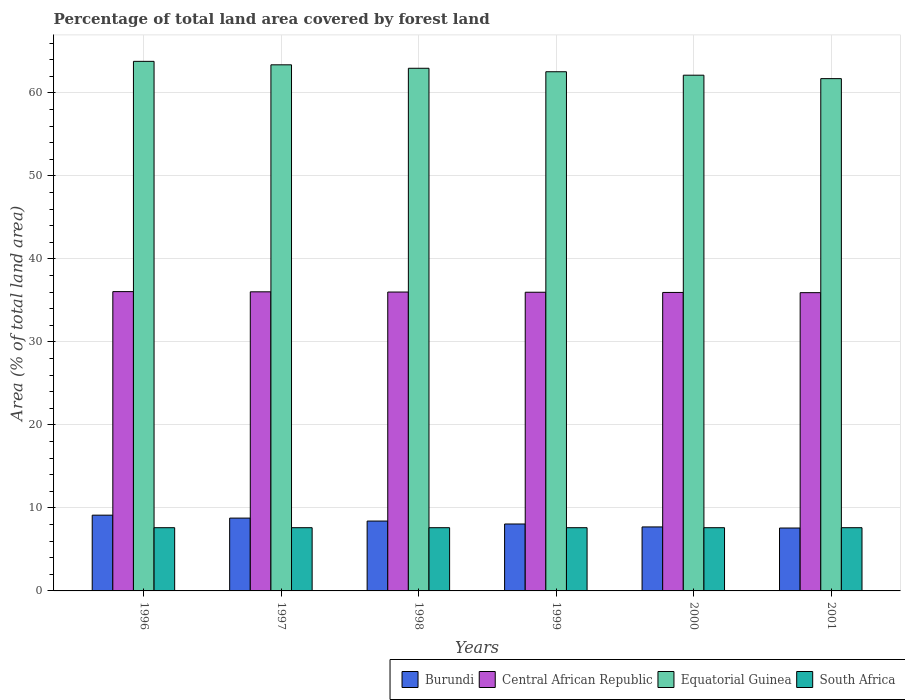How many groups of bars are there?
Offer a very short reply. 6. Are the number of bars per tick equal to the number of legend labels?
Your answer should be compact. Yes. Are the number of bars on each tick of the X-axis equal?
Your response must be concise. Yes. How many bars are there on the 1st tick from the left?
Offer a very short reply. 4. How many bars are there on the 5th tick from the right?
Provide a succinct answer. 4. What is the percentage of forest land in Burundi in 1999?
Provide a succinct answer. 8.06. Across all years, what is the maximum percentage of forest land in Burundi?
Offer a very short reply. 9.13. Across all years, what is the minimum percentage of forest land in Central African Republic?
Provide a succinct answer. 35.94. In which year was the percentage of forest land in Central African Republic maximum?
Keep it short and to the point. 1996. What is the total percentage of forest land in Equatorial Guinea in the graph?
Your response must be concise. 376.59. What is the difference between the percentage of forest land in Burundi in 1997 and that in 2000?
Make the answer very short. 1.06. What is the difference between the percentage of forest land in Equatorial Guinea in 2001 and the percentage of forest land in South Africa in 1999?
Your answer should be compact. 54.11. What is the average percentage of forest land in Burundi per year?
Ensure brevity in your answer.  8.28. In the year 1998, what is the difference between the percentage of forest land in Central African Republic and percentage of forest land in Equatorial Guinea?
Your answer should be compact. -26.96. What is the ratio of the percentage of forest land in Equatorial Guinea in 1997 to that in 1999?
Your response must be concise. 1.01. Is the percentage of forest land in Burundi in 1996 less than that in 2000?
Provide a succinct answer. No. Is the difference between the percentage of forest land in Central African Republic in 1998 and 2001 greater than the difference between the percentage of forest land in Equatorial Guinea in 1998 and 2001?
Your response must be concise. No. What is the difference between the highest and the second highest percentage of forest land in South Africa?
Keep it short and to the point. 0. What is the difference between the highest and the lowest percentage of forest land in Central African Republic?
Offer a terse response. 0.13. In how many years, is the percentage of forest land in South Africa greater than the average percentage of forest land in South Africa taken over all years?
Provide a short and direct response. 6. Is the sum of the percentage of forest land in South Africa in 1996 and 1997 greater than the maximum percentage of forest land in Central African Republic across all years?
Offer a very short reply. No. What does the 4th bar from the left in 2001 represents?
Provide a short and direct response. South Africa. What does the 1st bar from the right in 1997 represents?
Your answer should be very brief. South Africa. Is it the case that in every year, the sum of the percentage of forest land in South Africa and percentage of forest land in Burundi is greater than the percentage of forest land in Equatorial Guinea?
Ensure brevity in your answer.  No. Are all the bars in the graph horizontal?
Provide a short and direct response. No. What is the difference between two consecutive major ticks on the Y-axis?
Your answer should be compact. 10. Does the graph contain grids?
Your answer should be very brief. Yes. How are the legend labels stacked?
Provide a succinct answer. Horizontal. What is the title of the graph?
Your answer should be compact. Percentage of total land area covered by forest land. Does "Uzbekistan" appear as one of the legend labels in the graph?
Your response must be concise. No. What is the label or title of the X-axis?
Offer a terse response. Years. What is the label or title of the Y-axis?
Provide a succinct answer. Area (% of total land area). What is the Area (% of total land area) of Burundi in 1996?
Make the answer very short. 9.13. What is the Area (% of total land area) of Central African Republic in 1996?
Provide a succinct answer. 36.06. What is the Area (% of total land area) of Equatorial Guinea in 1996?
Your response must be concise. 63.81. What is the Area (% of total land area) in South Africa in 1996?
Your answer should be very brief. 7.62. What is the Area (% of total land area) in Burundi in 1997?
Provide a short and direct response. 8.77. What is the Area (% of total land area) in Central African Republic in 1997?
Make the answer very short. 36.04. What is the Area (% of total land area) in Equatorial Guinea in 1997?
Your answer should be compact. 63.39. What is the Area (% of total land area) in South Africa in 1997?
Offer a very short reply. 7.62. What is the Area (% of total land area) in Burundi in 1998?
Offer a terse response. 8.42. What is the Area (% of total land area) in Central African Republic in 1998?
Offer a very short reply. 36.01. What is the Area (% of total land area) in Equatorial Guinea in 1998?
Ensure brevity in your answer.  62.97. What is the Area (% of total land area) in South Africa in 1998?
Give a very brief answer. 7.62. What is the Area (% of total land area) of Burundi in 1999?
Offer a very short reply. 8.06. What is the Area (% of total land area) of Central African Republic in 1999?
Provide a short and direct response. 35.99. What is the Area (% of total land area) of Equatorial Guinea in 1999?
Give a very brief answer. 62.56. What is the Area (% of total land area) in South Africa in 1999?
Your answer should be very brief. 7.62. What is the Area (% of total land area) in Burundi in 2000?
Keep it short and to the point. 7.71. What is the Area (% of total land area) in Central African Republic in 2000?
Give a very brief answer. 35.96. What is the Area (% of total land area) in Equatorial Guinea in 2000?
Your response must be concise. 62.14. What is the Area (% of total land area) of South Africa in 2000?
Your answer should be compact. 7.62. What is the Area (% of total land area) of Burundi in 2001?
Provide a short and direct response. 7.58. What is the Area (% of total land area) in Central African Republic in 2001?
Your response must be concise. 35.94. What is the Area (% of total land area) in Equatorial Guinea in 2001?
Keep it short and to the point. 61.73. What is the Area (% of total land area) in South Africa in 2001?
Give a very brief answer. 7.62. Across all years, what is the maximum Area (% of total land area) in Burundi?
Your response must be concise. 9.13. Across all years, what is the maximum Area (% of total land area) of Central African Republic?
Ensure brevity in your answer.  36.06. Across all years, what is the maximum Area (% of total land area) in Equatorial Guinea?
Provide a short and direct response. 63.81. Across all years, what is the maximum Area (% of total land area) of South Africa?
Keep it short and to the point. 7.62. Across all years, what is the minimum Area (% of total land area) in Burundi?
Offer a terse response. 7.58. Across all years, what is the minimum Area (% of total land area) in Central African Republic?
Ensure brevity in your answer.  35.94. Across all years, what is the minimum Area (% of total land area) in Equatorial Guinea?
Your response must be concise. 61.73. Across all years, what is the minimum Area (% of total land area) in South Africa?
Keep it short and to the point. 7.62. What is the total Area (% of total land area) of Burundi in the graph?
Provide a short and direct response. 49.67. What is the total Area (% of total land area) of Central African Republic in the graph?
Provide a short and direct response. 216. What is the total Area (% of total land area) in Equatorial Guinea in the graph?
Ensure brevity in your answer.  376.59. What is the total Area (% of total land area) in South Africa in the graph?
Provide a short and direct response. 45.71. What is the difference between the Area (% of total land area) of Burundi in 1996 and that in 1997?
Keep it short and to the point. 0.35. What is the difference between the Area (% of total land area) of Central African Republic in 1996 and that in 1997?
Keep it short and to the point. 0.03. What is the difference between the Area (% of total land area) in Equatorial Guinea in 1996 and that in 1997?
Ensure brevity in your answer.  0.42. What is the difference between the Area (% of total land area) in Burundi in 1996 and that in 1998?
Your response must be concise. 0.71. What is the difference between the Area (% of total land area) of Central African Republic in 1996 and that in 1998?
Provide a succinct answer. 0.05. What is the difference between the Area (% of total land area) in Equatorial Guinea in 1996 and that in 1998?
Your response must be concise. 0.83. What is the difference between the Area (% of total land area) in South Africa in 1996 and that in 1998?
Make the answer very short. 0. What is the difference between the Area (% of total land area) in Burundi in 1996 and that in 1999?
Your response must be concise. 1.06. What is the difference between the Area (% of total land area) of Central African Republic in 1996 and that in 1999?
Offer a very short reply. 0.08. What is the difference between the Area (% of total land area) in Equatorial Guinea in 1996 and that in 1999?
Your answer should be very brief. 1.25. What is the difference between the Area (% of total land area) in Burundi in 1996 and that in 2000?
Your response must be concise. 1.42. What is the difference between the Area (% of total land area) in Central African Republic in 1996 and that in 2000?
Your answer should be very brief. 0.1. What is the difference between the Area (% of total land area) in Equatorial Guinea in 1996 and that in 2000?
Your answer should be compact. 1.67. What is the difference between the Area (% of total land area) of Burundi in 1996 and that in 2001?
Provide a succinct answer. 1.55. What is the difference between the Area (% of total land area) in Central African Republic in 1996 and that in 2001?
Keep it short and to the point. 0.13. What is the difference between the Area (% of total land area) in Equatorial Guinea in 1996 and that in 2001?
Provide a succinct answer. 2.08. What is the difference between the Area (% of total land area) in Burundi in 1997 and that in 1998?
Provide a short and direct response. 0.35. What is the difference between the Area (% of total land area) in Central African Republic in 1997 and that in 1998?
Keep it short and to the point. 0.03. What is the difference between the Area (% of total land area) in Equatorial Guinea in 1997 and that in 1998?
Keep it short and to the point. 0.42. What is the difference between the Area (% of total land area) of South Africa in 1997 and that in 1998?
Provide a succinct answer. 0. What is the difference between the Area (% of total land area) of Burundi in 1997 and that in 1999?
Ensure brevity in your answer.  0.71. What is the difference between the Area (% of total land area) of Central African Republic in 1997 and that in 1999?
Provide a short and direct response. 0.05. What is the difference between the Area (% of total land area) of Equatorial Guinea in 1997 and that in 1999?
Provide a short and direct response. 0.83. What is the difference between the Area (% of total land area) in South Africa in 1997 and that in 1999?
Offer a terse response. 0. What is the difference between the Area (% of total land area) of Burundi in 1997 and that in 2000?
Give a very brief answer. 1.06. What is the difference between the Area (% of total land area) of Central African Republic in 1997 and that in 2000?
Ensure brevity in your answer.  0.08. What is the difference between the Area (% of total land area) of Equatorial Guinea in 1997 and that in 2000?
Make the answer very short. 1.25. What is the difference between the Area (% of total land area) of South Africa in 1997 and that in 2000?
Ensure brevity in your answer.  0. What is the difference between the Area (% of total land area) in Burundi in 1997 and that in 2001?
Give a very brief answer. 1.2. What is the difference between the Area (% of total land area) in Central African Republic in 1997 and that in 2001?
Provide a succinct answer. 0.1. What is the difference between the Area (% of total land area) of Equatorial Guinea in 1997 and that in 2001?
Provide a short and direct response. 1.66. What is the difference between the Area (% of total land area) of Burundi in 1998 and that in 1999?
Offer a terse response. 0.35. What is the difference between the Area (% of total land area) of Central African Republic in 1998 and that in 1999?
Keep it short and to the point. 0.03. What is the difference between the Area (% of total land area) in Equatorial Guinea in 1998 and that in 1999?
Your response must be concise. 0.42. What is the difference between the Area (% of total land area) of South Africa in 1998 and that in 1999?
Your answer should be compact. 0. What is the difference between the Area (% of total land area) of Burundi in 1998 and that in 2000?
Provide a short and direct response. 0.71. What is the difference between the Area (% of total land area) in Central African Republic in 1998 and that in 2000?
Provide a succinct answer. 0.05. What is the difference between the Area (% of total land area) in Equatorial Guinea in 1998 and that in 2000?
Your response must be concise. 0.83. What is the difference between the Area (% of total land area) in Burundi in 1998 and that in 2001?
Provide a short and direct response. 0.84. What is the difference between the Area (% of total land area) in Central African Republic in 1998 and that in 2001?
Your response must be concise. 0.08. What is the difference between the Area (% of total land area) in Equatorial Guinea in 1998 and that in 2001?
Your answer should be very brief. 1.25. What is the difference between the Area (% of total land area) in Burundi in 1999 and that in 2000?
Make the answer very short. 0.35. What is the difference between the Area (% of total land area) of Central African Republic in 1999 and that in 2000?
Your answer should be very brief. 0.03. What is the difference between the Area (% of total land area) in Equatorial Guinea in 1999 and that in 2000?
Your response must be concise. 0.42. What is the difference between the Area (% of total land area) of South Africa in 1999 and that in 2000?
Keep it short and to the point. 0. What is the difference between the Area (% of total land area) of Burundi in 1999 and that in 2001?
Keep it short and to the point. 0.49. What is the difference between the Area (% of total land area) of Central African Republic in 1999 and that in 2001?
Keep it short and to the point. 0.05. What is the difference between the Area (% of total land area) in Equatorial Guinea in 1999 and that in 2001?
Your answer should be compact. 0.83. What is the difference between the Area (% of total land area) of Burundi in 2000 and that in 2001?
Your answer should be compact. 0.13. What is the difference between the Area (% of total land area) in Central African Republic in 2000 and that in 2001?
Ensure brevity in your answer.  0.03. What is the difference between the Area (% of total land area) of Equatorial Guinea in 2000 and that in 2001?
Your answer should be compact. 0.41. What is the difference between the Area (% of total land area) in South Africa in 2000 and that in 2001?
Make the answer very short. 0. What is the difference between the Area (% of total land area) in Burundi in 1996 and the Area (% of total land area) in Central African Republic in 1997?
Give a very brief answer. -26.91. What is the difference between the Area (% of total land area) in Burundi in 1996 and the Area (% of total land area) in Equatorial Guinea in 1997?
Keep it short and to the point. -54.26. What is the difference between the Area (% of total land area) of Burundi in 1996 and the Area (% of total land area) of South Africa in 1997?
Ensure brevity in your answer.  1.51. What is the difference between the Area (% of total land area) in Central African Republic in 1996 and the Area (% of total land area) in Equatorial Guinea in 1997?
Give a very brief answer. -27.33. What is the difference between the Area (% of total land area) in Central African Republic in 1996 and the Area (% of total land area) in South Africa in 1997?
Your answer should be compact. 28.45. What is the difference between the Area (% of total land area) of Equatorial Guinea in 1996 and the Area (% of total land area) of South Africa in 1997?
Offer a very short reply. 56.19. What is the difference between the Area (% of total land area) in Burundi in 1996 and the Area (% of total land area) in Central African Republic in 1998?
Your answer should be very brief. -26.89. What is the difference between the Area (% of total land area) in Burundi in 1996 and the Area (% of total land area) in Equatorial Guinea in 1998?
Keep it short and to the point. -53.85. What is the difference between the Area (% of total land area) in Burundi in 1996 and the Area (% of total land area) in South Africa in 1998?
Your response must be concise. 1.51. What is the difference between the Area (% of total land area) of Central African Republic in 1996 and the Area (% of total land area) of Equatorial Guinea in 1998?
Ensure brevity in your answer.  -26.91. What is the difference between the Area (% of total land area) of Central African Republic in 1996 and the Area (% of total land area) of South Africa in 1998?
Your response must be concise. 28.45. What is the difference between the Area (% of total land area) of Equatorial Guinea in 1996 and the Area (% of total land area) of South Africa in 1998?
Offer a terse response. 56.19. What is the difference between the Area (% of total land area) in Burundi in 1996 and the Area (% of total land area) in Central African Republic in 1999?
Give a very brief answer. -26.86. What is the difference between the Area (% of total land area) of Burundi in 1996 and the Area (% of total land area) of Equatorial Guinea in 1999?
Your answer should be very brief. -53.43. What is the difference between the Area (% of total land area) of Burundi in 1996 and the Area (% of total land area) of South Africa in 1999?
Offer a very short reply. 1.51. What is the difference between the Area (% of total land area) in Central African Republic in 1996 and the Area (% of total land area) in Equatorial Guinea in 1999?
Give a very brief answer. -26.49. What is the difference between the Area (% of total land area) of Central African Republic in 1996 and the Area (% of total land area) of South Africa in 1999?
Your answer should be compact. 28.45. What is the difference between the Area (% of total land area) in Equatorial Guinea in 1996 and the Area (% of total land area) in South Africa in 1999?
Your answer should be compact. 56.19. What is the difference between the Area (% of total land area) of Burundi in 1996 and the Area (% of total land area) of Central African Republic in 2000?
Give a very brief answer. -26.83. What is the difference between the Area (% of total land area) of Burundi in 1996 and the Area (% of total land area) of Equatorial Guinea in 2000?
Offer a very short reply. -53.01. What is the difference between the Area (% of total land area) in Burundi in 1996 and the Area (% of total land area) in South Africa in 2000?
Ensure brevity in your answer.  1.51. What is the difference between the Area (% of total land area) in Central African Republic in 1996 and the Area (% of total land area) in Equatorial Guinea in 2000?
Your answer should be very brief. -26.08. What is the difference between the Area (% of total land area) in Central African Republic in 1996 and the Area (% of total land area) in South Africa in 2000?
Your answer should be compact. 28.45. What is the difference between the Area (% of total land area) of Equatorial Guinea in 1996 and the Area (% of total land area) of South Africa in 2000?
Offer a very short reply. 56.19. What is the difference between the Area (% of total land area) of Burundi in 1996 and the Area (% of total land area) of Central African Republic in 2001?
Make the answer very short. -26.81. What is the difference between the Area (% of total land area) in Burundi in 1996 and the Area (% of total land area) in Equatorial Guinea in 2001?
Keep it short and to the point. -52.6. What is the difference between the Area (% of total land area) in Burundi in 1996 and the Area (% of total land area) in South Africa in 2001?
Your answer should be very brief. 1.51. What is the difference between the Area (% of total land area) in Central African Republic in 1996 and the Area (% of total land area) in Equatorial Guinea in 2001?
Keep it short and to the point. -25.66. What is the difference between the Area (% of total land area) in Central African Republic in 1996 and the Area (% of total land area) in South Africa in 2001?
Make the answer very short. 28.45. What is the difference between the Area (% of total land area) in Equatorial Guinea in 1996 and the Area (% of total land area) in South Africa in 2001?
Ensure brevity in your answer.  56.19. What is the difference between the Area (% of total land area) in Burundi in 1997 and the Area (% of total land area) in Central African Republic in 1998?
Make the answer very short. -27.24. What is the difference between the Area (% of total land area) of Burundi in 1997 and the Area (% of total land area) of Equatorial Guinea in 1998?
Ensure brevity in your answer.  -54.2. What is the difference between the Area (% of total land area) in Burundi in 1997 and the Area (% of total land area) in South Africa in 1998?
Provide a short and direct response. 1.16. What is the difference between the Area (% of total land area) in Central African Republic in 1997 and the Area (% of total land area) in Equatorial Guinea in 1998?
Your answer should be very brief. -26.94. What is the difference between the Area (% of total land area) in Central African Republic in 1997 and the Area (% of total land area) in South Africa in 1998?
Your response must be concise. 28.42. What is the difference between the Area (% of total land area) in Equatorial Guinea in 1997 and the Area (% of total land area) in South Africa in 1998?
Give a very brief answer. 55.77. What is the difference between the Area (% of total land area) in Burundi in 1997 and the Area (% of total land area) in Central African Republic in 1999?
Your answer should be very brief. -27.21. What is the difference between the Area (% of total land area) of Burundi in 1997 and the Area (% of total land area) of Equatorial Guinea in 1999?
Offer a terse response. -53.78. What is the difference between the Area (% of total land area) in Burundi in 1997 and the Area (% of total land area) in South Africa in 1999?
Make the answer very short. 1.16. What is the difference between the Area (% of total land area) of Central African Republic in 1997 and the Area (% of total land area) of Equatorial Guinea in 1999?
Keep it short and to the point. -26.52. What is the difference between the Area (% of total land area) in Central African Republic in 1997 and the Area (% of total land area) in South Africa in 1999?
Offer a very short reply. 28.42. What is the difference between the Area (% of total land area) in Equatorial Guinea in 1997 and the Area (% of total land area) in South Africa in 1999?
Provide a short and direct response. 55.77. What is the difference between the Area (% of total land area) of Burundi in 1997 and the Area (% of total land area) of Central African Republic in 2000?
Give a very brief answer. -27.19. What is the difference between the Area (% of total land area) of Burundi in 1997 and the Area (% of total land area) of Equatorial Guinea in 2000?
Your answer should be very brief. -53.37. What is the difference between the Area (% of total land area) of Burundi in 1997 and the Area (% of total land area) of South Africa in 2000?
Ensure brevity in your answer.  1.16. What is the difference between the Area (% of total land area) in Central African Republic in 1997 and the Area (% of total land area) in Equatorial Guinea in 2000?
Your answer should be very brief. -26.1. What is the difference between the Area (% of total land area) in Central African Republic in 1997 and the Area (% of total land area) in South Africa in 2000?
Offer a terse response. 28.42. What is the difference between the Area (% of total land area) in Equatorial Guinea in 1997 and the Area (% of total land area) in South Africa in 2000?
Offer a terse response. 55.77. What is the difference between the Area (% of total land area) of Burundi in 1997 and the Area (% of total land area) of Central African Republic in 2001?
Offer a very short reply. -27.16. What is the difference between the Area (% of total land area) in Burundi in 1997 and the Area (% of total land area) in Equatorial Guinea in 2001?
Offer a terse response. -52.95. What is the difference between the Area (% of total land area) in Burundi in 1997 and the Area (% of total land area) in South Africa in 2001?
Make the answer very short. 1.16. What is the difference between the Area (% of total land area) of Central African Republic in 1997 and the Area (% of total land area) of Equatorial Guinea in 2001?
Keep it short and to the point. -25.69. What is the difference between the Area (% of total land area) in Central African Republic in 1997 and the Area (% of total land area) in South Africa in 2001?
Give a very brief answer. 28.42. What is the difference between the Area (% of total land area) of Equatorial Guinea in 1997 and the Area (% of total land area) of South Africa in 2001?
Make the answer very short. 55.77. What is the difference between the Area (% of total land area) of Burundi in 1998 and the Area (% of total land area) of Central African Republic in 1999?
Your answer should be very brief. -27.57. What is the difference between the Area (% of total land area) in Burundi in 1998 and the Area (% of total land area) in Equatorial Guinea in 1999?
Keep it short and to the point. -54.14. What is the difference between the Area (% of total land area) of Burundi in 1998 and the Area (% of total land area) of South Africa in 1999?
Give a very brief answer. 0.8. What is the difference between the Area (% of total land area) of Central African Republic in 1998 and the Area (% of total land area) of Equatorial Guinea in 1999?
Your response must be concise. -26.54. What is the difference between the Area (% of total land area) in Central African Republic in 1998 and the Area (% of total land area) in South Africa in 1999?
Offer a terse response. 28.39. What is the difference between the Area (% of total land area) in Equatorial Guinea in 1998 and the Area (% of total land area) in South Africa in 1999?
Offer a terse response. 55.36. What is the difference between the Area (% of total land area) in Burundi in 1998 and the Area (% of total land area) in Central African Republic in 2000?
Your answer should be compact. -27.54. What is the difference between the Area (% of total land area) in Burundi in 1998 and the Area (% of total land area) in Equatorial Guinea in 2000?
Provide a short and direct response. -53.72. What is the difference between the Area (% of total land area) in Burundi in 1998 and the Area (% of total land area) in South Africa in 2000?
Your response must be concise. 0.8. What is the difference between the Area (% of total land area) in Central African Republic in 1998 and the Area (% of total land area) in Equatorial Guinea in 2000?
Your answer should be very brief. -26.13. What is the difference between the Area (% of total land area) in Central African Republic in 1998 and the Area (% of total land area) in South Africa in 2000?
Offer a terse response. 28.39. What is the difference between the Area (% of total land area) in Equatorial Guinea in 1998 and the Area (% of total land area) in South Africa in 2000?
Provide a succinct answer. 55.36. What is the difference between the Area (% of total land area) of Burundi in 1998 and the Area (% of total land area) of Central African Republic in 2001?
Give a very brief answer. -27.52. What is the difference between the Area (% of total land area) of Burundi in 1998 and the Area (% of total land area) of Equatorial Guinea in 2001?
Give a very brief answer. -53.31. What is the difference between the Area (% of total land area) of Burundi in 1998 and the Area (% of total land area) of South Africa in 2001?
Offer a terse response. 0.8. What is the difference between the Area (% of total land area) of Central African Republic in 1998 and the Area (% of total land area) of Equatorial Guinea in 2001?
Your answer should be compact. -25.71. What is the difference between the Area (% of total land area) in Central African Republic in 1998 and the Area (% of total land area) in South Africa in 2001?
Make the answer very short. 28.39. What is the difference between the Area (% of total land area) in Equatorial Guinea in 1998 and the Area (% of total land area) in South Africa in 2001?
Ensure brevity in your answer.  55.36. What is the difference between the Area (% of total land area) in Burundi in 1999 and the Area (% of total land area) in Central African Republic in 2000?
Give a very brief answer. -27.9. What is the difference between the Area (% of total land area) in Burundi in 1999 and the Area (% of total land area) in Equatorial Guinea in 2000?
Keep it short and to the point. -54.07. What is the difference between the Area (% of total land area) in Burundi in 1999 and the Area (% of total land area) in South Africa in 2000?
Give a very brief answer. 0.45. What is the difference between the Area (% of total land area) in Central African Republic in 1999 and the Area (% of total land area) in Equatorial Guinea in 2000?
Your response must be concise. -26.15. What is the difference between the Area (% of total land area) of Central African Republic in 1999 and the Area (% of total land area) of South Africa in 2000?
Give a very brief answer. 28.37. What is the difference between the Area (% of total land area) of Equatorial Guinea in 1999 and the Area (% of total land area) of South Africa in 2000?
Give a very brief answer. 54.94. What is the difference between the Area (% of total land area) of Burundi in 1999 and the Area (% of total land area) of Central African Republic in 2001?
Give a very brief answer. -27.87. What is the difference between the Area (% of total land area) of Burundi in 1999 and the Area (% of total land area) of Equatorial Guinea in 2001?
Offer a terse response. -53.66. What is the difference between the Area (% of total land area) of Burundi in 1999 and the Area (% of total land area) of South Africa in 2001?
Your answer should be compact. 0.45. What is the difference between the Area (% of total land area) of Central African Republic in 1999 and the Area (% of total land area) of Equatorial Guinea in 2001?
Offer a terse response. -25.74. What is the difference between the Area (% of total land area) in Central African Republic in 1999 and the Area (% of total land area) in South Africa in 2001?
Provide a short and direct response. 28.37. What is the difference between the Area (% of total land area) of Equatorial Guinea in 1999 and the Area (% of total land area) of South Africa in 2001?
Provide a succinct answer. 54.94. What is the difference between the Area (% of total land area) of Burundi in 2000 and the Area (% of total land area) of Central African Republic in 2001?
Keep it short and to the point. -28.23. What is the difference between the Area (% of total land area) in Burundi in 2000 and the Area (% of total land area) in Equatorial Guinea in 2001?
Offer a very short reply. -54.02. What is the difference between the Area (% of total land area) of Burundi in 2000 and the Area (% of total land area) of South Africa in 2001?
Your answer should be very brief. 0.09. What is the difference between the Area (% of total land area) in Central African Republic in 2000 and the Area (% of total land area) in Equatorial Guinea in 2001?
Your response must be concise. -25.76. What is the difference between the Area (% of total land area) in Central African Republic in 2000 and the Area (% of total land area) in South Africa in 2001?
Provide a short and direct response. 28.34. What is the difference between the Area (% of total land area) in Equatorial Guinea in 2000 and the Area (% of total land area) in South Africa in 2001?
Your response must be concise. 54.52. What is the average Area (% of total land area) in Burundi per year?
Your answer should be compact. 8.28. What is the average Area (% of total land area) in Central African Republic per year?
Provide a short and direct response. 36. What is the average Area (% of total land area) of Equatorial Guinea per year?
Your response must be concise. 62.77. What is the average Area (% of total land area) in South Africa per year?
Offer a terse response. 7.62. In the year 1996, what is the difference between the Area (% of total land area) of Burundi and Area (% of total land area) of Central African Republic?
Keep it short and to the point. -26.94. In the year 1996, what is the difference between the Area (% of total land area) of Burundi and Area (% of total land area) of Equatorial Guinea?
Keep it short and to the point. -54.68. In the year 1996, what is the difference between the Area (% of total land area) in Burundi and Area (% of total land area) in South Africa?
Provide a short and direct response. 1.51. In the year 1996, what is the difference between the Area (% of total land area) of Central African Republic and Area (% of total land area) of Equatorial Guinea?
Make the answer very short. -27.74. In the year 1996, what is the difference between the Area (% of total land area) in Central African Republic and Area (% of total land area) in South Africa?
Provide a succinct answer. 28.45. In the year 1996, what is the difference between the Area (% of total land area) of Equatorial Guinea and Area (% of total land area) of South Africa?
Make the answer very short. 56.19. In the year 1997, what is the difference between the Area (% of total land area) in Burundi and Area (% of total land area) in Central African Republic?
Make the answer very short. -27.26. In the year 1997, what is the difference between the Area (% of total land area) in Burundi and Area (% of total land area) in Equatorial Guinea?
Keep it short and to the point. -54.62. In the year 1997, what is the difference between the Area (% of total land area) in Burundi and Area (% of total land area) in South Africa?
Your answer should be compact. 1.16. In the year 1997, what is the difference between the Area (% of total land area) of Central African Republic and Area (% of total land area) of Equatorial Guinea?
Your response must be concise. -27.35. In the year 1997, what is the difference between the Area (% of total land area) in Central African Republic and Area (% of total land area) in South Africa?
Your answer should be very brief. 28.42. In the year 1997, what is the difference between the Area (% of total land area) of Equatorial Guinea and Area (% of total land area) of South Africa?
Provide a short and direct response. 55.77. In the year 1998, what is the difference between the Area (% of total land area) of Burundi and Area (% of total land area) of Central African Republic?
Give a very brief answer. -27.59. In the year 1998, what is the difference between the Area (% of total land area) in Burundi and Area (% of total land area) in Equatorial Guinea?
Give a very brief answer. -54.55. In the year 1998, what is the difference between the Area (% of total land area) in Burundi and Area (% of total land area) in South Africa?
Give a very brief answer. 0.8. In the year 1998, what is the difference between the Area (% of total land area) of Central African Republic and Area (% of total land area) of Equatorial Guinea?
Give a very brief answer. -26.96. In the year 1998, what is the difference between the Area (% of total land area) in Central African Republic and Area (% of total land area) in South Africa?
Provide a short and direct response. 28.39. In the year 1998, what is the difference between the Area (% of total land area) in Equatorial Guinea and Area (% of total land area) in South Africa?
Your answer should be compact. 55.36. In the year 1999, what is the difference between the Area (% of total land area) of Burundi and Area (% of total land area) of Central African Republic?
Give a very brief answer. -27.92. In the year 1999, what is the difference between the Area (% of total land area) in Burundi and Area (% of total land area) in Equatorial Guinea?
Your answer should be very brief. -54.49. In the year 1999, what is the difference between the Area (% of total land area) in Burundi and Area (% of total land area) in South Africa?
Provide a short and direct response. 0.45. In the year 1999, what is the difference between the Area (% of total land area) of Central African Republic and Area (% of total land area) of Equatorial Guinea?
Ensure brevity in your answer.  -26.57. In the year 1999, what is the difference between the Area (% of total land area) in Central African Republic and Area (% of total land area) in South Africa?
Ensure brevity in your answer.  28.37. In the year 1999, what is the difference between the Area (% of total land area) of Equatorial Guinea and Area (% of total land area) of South Africa?
Make the answer very short. 54.94. In the year 2000, what is the difference between the Area (% of total land area) in Burundi and Area (% of total land area) in Central African Republic?
Your response must be concise. -28.25. In the year 2000, what is the difference between the Area (% of total land area) in Burundi and Area (% of total land area) in Equatorial Guinea?
Your response must be concise. -54.43. In the year 2000, what is the difference between the Area (% of total land area) in Burundi and Area (% of total land area) in South Africa?
Provide a short and direct response. 0.09. In the year 2000, what is the difference between the Area (% of total land area) of Central African Republic and Area (% of total land area) of Equatorial Guinea?
Ensure brevity in your answer.  -26.18. In the year 2000, what is the difference between the Area (% of total land area) in Central African Republic and Area (% of total land area) in South Africa?
Your answer should be compact. 28.34. In the year 2000, what is the difference between the Area (% of total land area) in Equatorial Guinea and Area (% of total land area) in South Africa?
Your answer should be compact. 54.52. In the year 2001, what is the difference between the Area (% of total land area) of Burundi and Area (% of total land area) of Central African Republic?
Offer a terse response. -28.36. In the year 2001, what is the difference between the Area (% of total land area) of Burundi and Area (% of total land area) of Equatorial Guinea?
Your response must be concise. -54.15. In the year 2001, what is the difference between the Area (% of total land area) of Burundi and Area (% of total land area) of South Africa?
Provide a succinct answer. -0.04. In the year 2001, what is the difference between the Area (% of total land area) in Central African Republic and Area (% of total land area) in Equatorial Guinea?
Make the answer very short. -25.79. In the year 2001, what is the difference between the Area (% of total land area) in Central African Republic and Area (% of total land area) in South Africa?
Offer a very short reply. 28.32. In the year 2001, what is the difference between the Area (% of total land area) of Equatorial Guinea and Area (% of total land area) of South Africa?
Your answer should be compact. 54.11. What is the ratio of the Area (% of total land area) in Burundi in 1996 to that in 1997?
Offer a terse response. 1.04. What is the ratio of the Area (% of total land area) of Equatorial Guinea in 1996 to that in 1997?
Keep it short and to the point. 1.01. What is the ratio of the Area (% of total land area) of South Africa in 1996 to that in 1997?
Keep it short and to the point. 1. What is the ratio of the Area (% of total land area) of Burundi in 1996 to that in 1998?
Make the answer very short. 1.08. What is the ratio of the Area (% of total land area) in Central African Republic in 1996 to that in 1998?
Keep it short and to the point. 1. What is the ratio of the Area (% of total land area) of Equatorial Guinea in 1996 to that in 1998?
Offer a very short reply. 1.01. What is the ratio of the Area (% of total land area) of Burundi in 1996 to that in 1999?
Offer a terse response. 1.13. What is the ratio of the Area (% of total land area) in South Africa in 1996 to that in 1999?
Your answer should be very brief. 1. What is the ratio of the Area (% of total land area) of Burundi in 1996 to that in 2000?
Give a very brief answer. 1.18. What is the ratio of the Area (% of total land area) of Central African Republic in 1996 to that in 2000?
Provide a short and direct response. 1. What is the ratio of the Area (% of total land area) of Equatorial Guinea in 1996 to that in 2000?
Your answer should be compact. 1.03. What is the ratio of the Area (% of total land area) in Burundi in 1996 to that in 2001?
Your answer should be very brief. 1.2. What is the ratio of the Area (% of total land area) in Equatorial Guinea in 1996 to that in 2001?
Offer a very short reply. 1.03. What is the ratio of the Area (% of total land area) in Burundi in 1997 to that in 1998?
Make the answer very short. 1.04. What is the ratio of the Area (% of total land area) in Equatorial Guinea in 1997 to that in 1998?
Keep it short and to the point. 1.01. What is the ratio of the Area (% of total land area) in South Africa in 1997 to that in 1998?
Provide a short and direct response. 1. What is the ratio of the Area (% of total land area) in Burundi in 1997 to that in 1999?
Keep it short and to the point. 1.09. What is the ratio of the Area (% of total land area) in Equatorial Guinea in 1997 to that in 1999?
Give a very brief answer. 1.01. What is the ratio of the Area (% of total land area) of South Africa in 1997 to that in 1999?
Make the answer very short. 1. What is the ratio of the Area (% of total land area) in Burundi in 1997 to that in 2000?
Provide a succinct answer. 1.14. What is the ratio of the Area (% of total land area) in Central African Republic in 1997 to that in 2000?
Offer a terse response. 1. What is the ratio of the Area (% of total land area) of Equatorial Guinea in 1997 to that in 2000?
Ensure brevity in your answer.  1.02. What is the ratio of the Area (% of total land area) in South Africa in 1997 to that in 2000?
Make the answer very short. 1. What is the ratio of the Area (% of total land area) in Burundi in 1997 to that in 2001?
Make the answer very short. 1.16. What is the ratio of the Area (% of total land area) of Central African Republic in 1997 to that in 2001?
Your answer should be very brief. 1. What is the ratio of the Area (% of total land area) in South Africa in 1997 to that in 2001?
Provide a succinct answer. 1. What is the ratio of the Area (% of total land area) in Burundi in 1998 to that in 1999?
Provide a succinct answer. 1.04. What is the ratio of the Area (% of total land area) in Central African Republic in 1998 to that in 1999?
Make the answer very short. 1. What is the ratio of the Area (% of total land area) of Burundi in 1998 to that in 2000?
Provide a succinct answer. 1.09. What is the ratio of the Area (% of total land area) in Central African Republic in 1998 to that in 2000?
Keep it short and to the point. 1. What is the ratio of the Area (% of total land area) in Equatorial Guinea in 1998 to that in 2000?
Offer a very short reply. 1.01. What is the ratio of the Area (% of total land area) in South Africa in 1998 to that in 2000?
Ensure brevity in your answer.  1. What is the ratio of the Area (% of total land area) in Burundi in 1998 to that in 2001?
Provide a succinct answer. 1.11. What is the ratio of the Area (% of total land area) in Equatorial Guinea in 1998 to that in 2001?
Offer a very short reply. 1.02. What is the ratio of the Area (% of total land area) of Burundi in 1999 to that in 2000?
Your response must be concise. 1.05. What is the ratio of the Area (% of total land area) in Equatorial Guinea in 1999 to that in 2000?
Keep it short and to the point. 1.01. What is the ratio of the Area (% of total land area) of South Africa in 1999 to that in 2000?
Ensure brevity in your answer.  1. What is the ratio of the Area (% of total land area) of Burundi in 1999 to that in 2001?
Your answer should be compact. 1.06. What is the ratio of the Area (% of total land area) in Central African Republic in 1999 to that in 2001?
Give a very brief answer. 1. What is the ratio of the Area (% of total land area) of Equatorial Guinea in 1999 to that in 2001?
Give a very brief answer. 1.01. What is the ratio of the Area (% of total land area) in Burundi in 2000 to that in 2001?
Give a very brief answer. 1.02. What is the ratio of the Area (% of total land area) of Central African Republic in 2000 to that in 2001?
Provide a succinct answer. 1. What is the ratio of the Area (% of total land area) of Equatorial Guinea in 2000 to that in 2001?
Provide a succinct answer. 1.01. What is the difference between the highest and the second highest Area (% of total land area) in Burundi?
Make the answer very short. 0.35. What is the difference between the highest and the second highest Area (% of total land area) of Central African Republic?
Your answer should be compact. 0.03. What is the difference between the highest and the second highest Area (% of total land area) in Equatorial Guinea?
Give a very brief answer. 0.42. What is the difference between the highest and the lowest Area (% of total land area) in Burundi?
Provide a short and direct response. 1.55. What is the difference between the highest and the lowest Area (% of total land area) in Central African Republic?
Your response must be concise. 0.13. What is the difference between the highest and the lowest Area (% of total land area) in Equatorial Guinea?
Provide a succinct answer. 2.08. What is the difference between the highest and the lowest Area (% of total land area) in South Africa?
Make the answer very short. 0. 